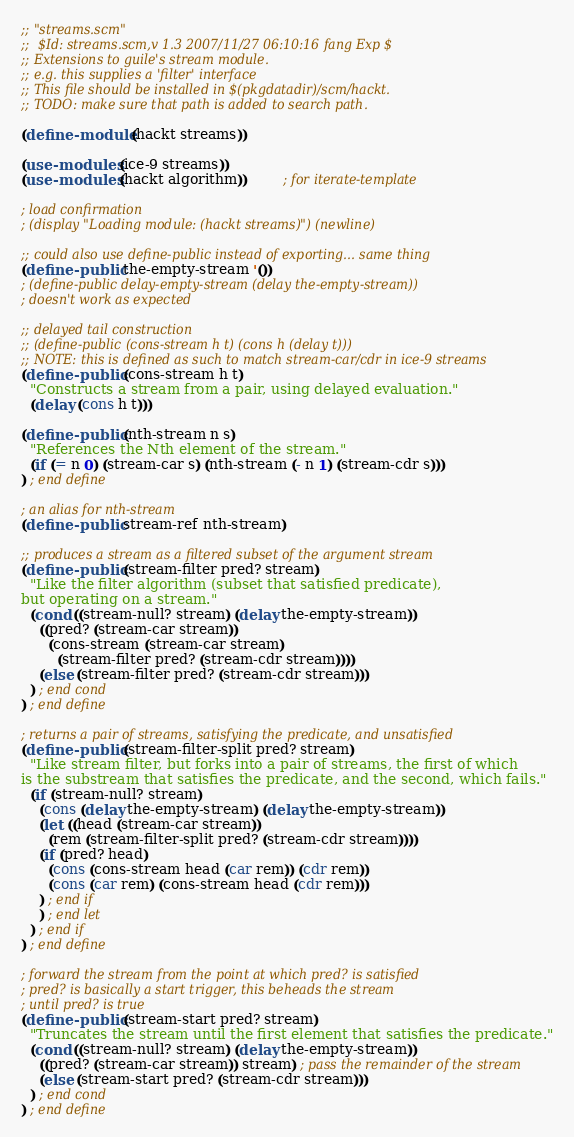<code> <loc_0><loc_0><loc_500><loc_500><_Scheme_>;; "streams.scm"
;;	$Id: streams.scm,v 1.3 2007/11/27 06:10:16 fang Exp $
;; Extensions to guile's stream module.
;; e.g. this supplies a 'filter' interface
;; This file should be installed in $(pkgdatadir)/scm/hackt.
;; TODO: make sure that path is added to search path.

(define-module (hackt streams))

(use-modules (ice-9 streams))
(use-modules (hackt algorithm))		; for iterate-template

; load confirmation
; (display "Loading module: (hackt streams)") (newline)

;; could also use define-public instead of exporting... same thing
(define-public the-empty-stream '())
; (define-public delay-empty-stream (delay the-empty-stream))
; doesn't work as expected

;; delayed tail construction
;; (define-public (cons-stream h t) (cons h (delay t)))
;; NOTE: this is defined as such to match stream-car/cdr in ice-9 streams
(define-public (cons-stream h t)
  "Constructs a stream from a pair, using delayed evaluation."
  (delay (cons h t)))

(define-public (nth-stream n s)
  "References the Nth element of the stream."
  (if (= n 0) (stream-car s) (nth-stream (- n 1) (stream-cdr s)))
) ; end define

; an alias for nth-stream
(define-public stream-ref nth-stream)

;; produces a stream as a filtered subset of the argument stream
(define-public (stream-filter pred? stream)
  "Like the filter algorithm (subset that satisfied predicate), 
but operating on a stream."
  (cond ((stream-null? stream) (delay the-empty-stream))
	((pred? (stream-car stream))
	  (cons-stream (stream-car stream)
		(stream-filter pred? (stream-cdr stream))))
	(else (stream-filter pred? (stream-cdr stream)))
  ) ; end cond
) ; end define

; returns a pair of streams, satisfying the predicate, and unsatisfied
(define-public (stream-filter-split pred? stream)
  "Like stream filter, but forks into a pair of streams, the first of which
is the substream that satisfies the predicate, and the second, which fails."
  (if (stream-null? stream)
    (cons (delay the-empty-stream) (delay the-empty-stream))
    (let ((head (stream-car stream))
	  (rem (stream-filter-split pred? (stream-cdr stream))))
	(if (pred? head)
	  (cons (cons-stream head (car rem)) (cdr rem))
	  (cons (car rem) (cons-stream head (cdr rem)))
	) ; end if
    ) ; end let
  ) ; end if
) ; end define

; forward the stream from the point at which pred? is satisfied
; pred? is basically a start trigger, this beheads the stream 
; until pred? is true
(define-public (stream-start pred? stream)
  "Truncates the stream until the first element that satisfies the predicate."
  (cond ((stream-null? stream) (delay the-empty-stream))
	((pred? (stream-car stream)) stream) ; pass the remainder of the stream
	(else (stream-start pred? (stream-cdr stream)))
  ) ; end cond
) ; end define
</code> 